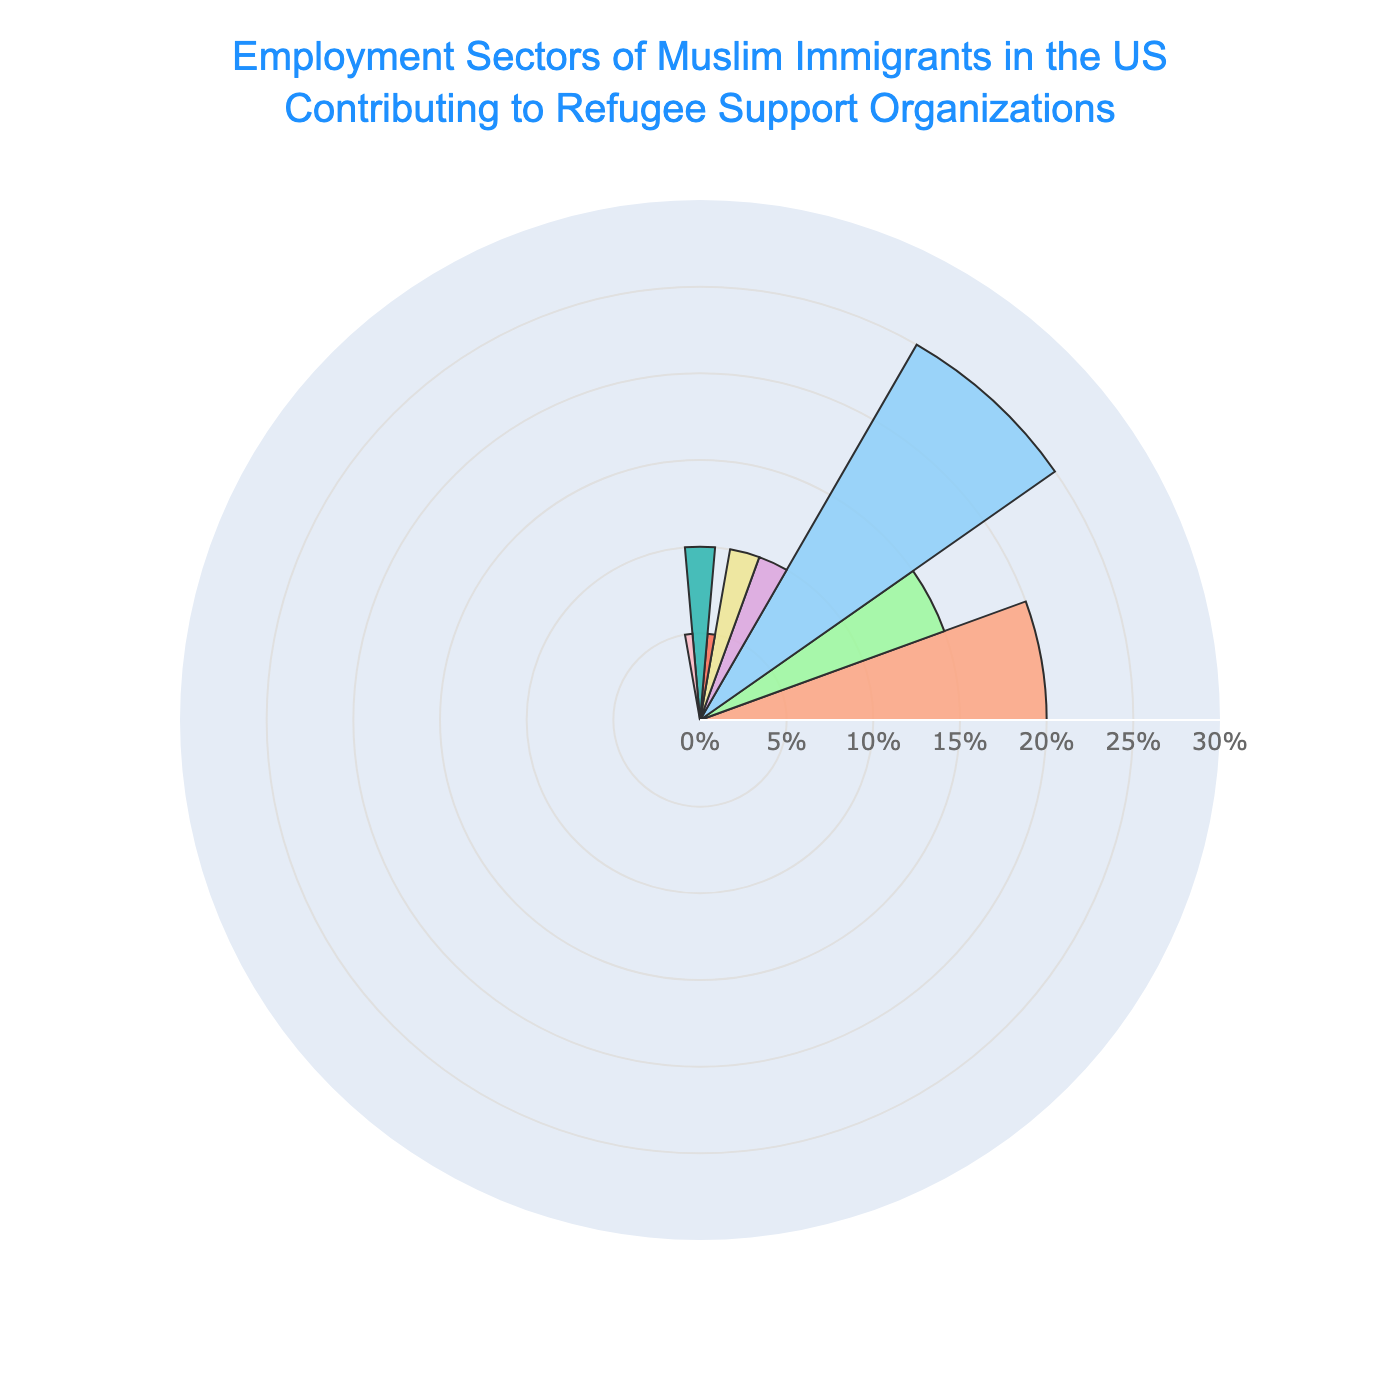How many sectors are represented in the rose chart? The title and visual segments help identify that the figure represents various employment sectors. Counting each distinct segment gives us the total number of sectors.
Answer: 8 What sector has the highest percentage of employment among Muslim immigrants? By looking at the lengths of the segments in the rose chart, the longest segment corresponds to the sector with the highest percentage.
Answer: Non-Profit/NGOs Which two sectors have the lowest percentage of employment? By identifying the two shortest segments in the rose chart, we can determine the sectors with the lowest percentages.
Answer: Public Administration, Legal Services How much higher is the percentage of people employed in healthcare compared to those in technology? Find the segment for healthcare and technology, and subtract the percentage of technology from healthcare.
Answer: 10% What is the combined percentage of employment in the Business/Corporate and Small Business/Entrepreneurship sectors? Add the percentages of Business/Corporate (10%) and Small Business/Entrepreneurship (10%).
Answer: 20% Which sector contributes more to refugee support organizations, Education or Healthcare? Compare the lengths of the segments for Education and Healthcare; the longer segment has a higher percentage.
Answer: Healthcare Is the percentage of employment in Technology and Business/Corporate combined greater than that in Non-Profit/NGOs? Add the percentages of Technology and Business/Corporate, then compare the sum to Non-Profit/NGOs.
Answer: No How many sectors have a percentage of 10% or higher? Identify and count the segments with percentages of 10% or more.
Answer: 5 What's the average percentage of employment across all sectors? Sum all the sector percentages and divide by the number of sectors. (20% + 15% + 25% + 10% + 10% + 5% + 10% + 5%) / 8
Answer: 12.5% What is the percentage difference between Non-Profit/NGOs and Public Administration? Subtract the percentage of Public Administration from Non-Profit/NGOs.
Answer: 20% 